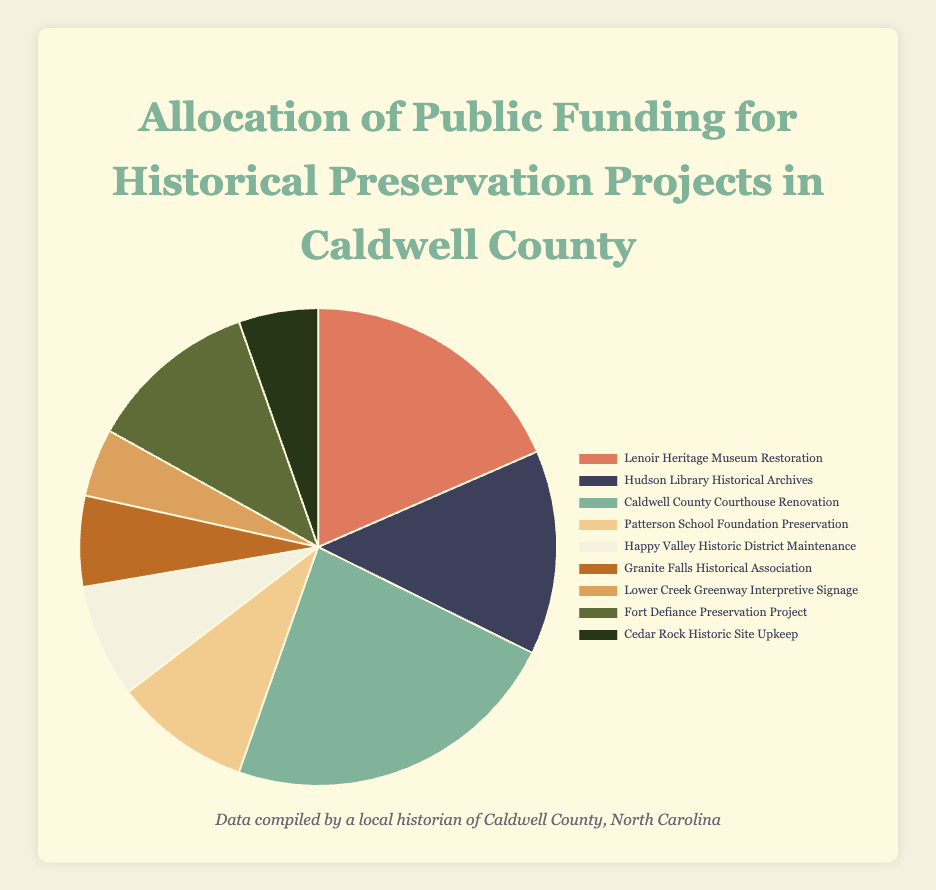Which project received the highest funding allocation? By inspecting the pie chart, we can identify the segment with the largest area. The label corresponding to that segment is "Caldwell County Courthouse Renovation."
Answer: Caldwell County Courthouse Renovation What is the combined funding allocation for the Lenoir Heritage Museum Restoration and the Hudson Library Historical Archives? To find the combined funding, add the allocations for both projects: $120,000 (Lenoir Heritage Museum Restoration) + $90,000 (Hudson Library Historical Archives) = $210,000.
Answer: $210,000 Which project received less funding: Granite Falls Historical Association or Cedar Rock Historic Site Upkeep? Compare the funding allocations: Granite Falls Historical Association ($40,000) and Cedar Rock Historic Site Upkeep ($35,000). Cedar Rock Historic Site Upkeep received less funding.
Answer: Cedar Rock Historic Site Upkeep How much more funding did the Fort Defiance Preservation Project receive compared to the Lower Creek Greenway Interpretive Signage? To determine the difference, subtract the funding for Lower Creek Greenway Interpretive Signage from the funding for Fort Defiance Preservation Project: $75,000 - $30,000 = $45,000.
Answer: $45,000 What is the average funding allocated across all projects? Calculate the total funding allocated by summing all values: $120,000 + $90,000 + $150,000 + $60,000 + $50,000 + $40,000 + $30,000 + $75,000 + $35,000 = $650,000. There are 9 projects, so the average is $650,000 / 9 ≈ $72,222.22.
Answer: $72,222.22 Which project is represented by the yellow segment in the pie chart? Refer to the legend and match the color with the project name. The yellow segment corresponds to the "Happy Valley Historic District Maintenance" project.
Answer: Happy Valley Historic District Maintenance How does the funding for the Patterson School Foundation Preservation compare to the Fort Defiance Preservation Project? The Patterson School Foundation Preservation received $60,000 while the Fort Defiance Preservation Project received $75,000. The Fort Defiance Preservation Project received $15,000 more.
Answer: Fort Defiance Preservation Project received $15,000 more What percentage of the total funding was allocated to the Caldwell County Courthouse Renovation project? First, calculate the total funding: $650,000. Then, find the percentage: ($150,000 / $650,000) * 100 ≈ 23.08%.
Answer: 23.08% Which project received the smallest funding allocation and how much was it? By looking at the pie chart segments for the smallest area, identify the project and its funding: "Lower Creek Greenway Interpretive Signage" received $30,000, the smallest allocation.
Answer: Lower Creek Greenway Interpretive Signage, $30,000 What is the funding difference between the Hudson Library Historical Archives and the Granite Falls Historical Association? Subtract the funding for Granite Falls Historical Association from the Hudson Library Historical Archives: $90,000 - $40,000 = $50,000.
Answer: $50,000 